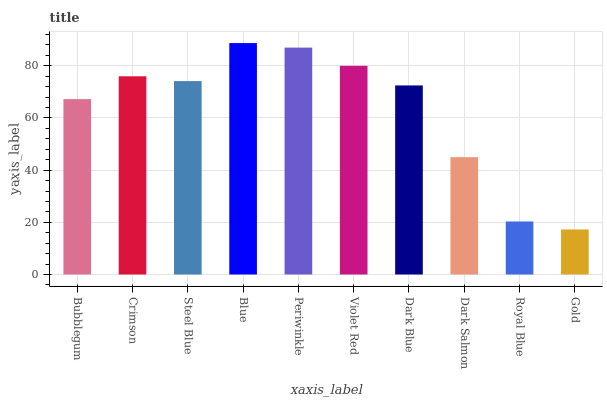Is Gold the minimum?
Answer yes or no. Yes. Is Blue the maximum?
Answer yes or no. Yes. Is Crimson the minimum?
Answer yes or no. No. Is Crimson the maximum?
Answer yes or no. No. Is Crimson greater than Bubblegum?
Answer yes or no. Yes. Is Bubblegum less than Crimson?
Answer yes or no. Yes. Is Bubblegum greater than Crimson?
Answer yes or no. No. Is Crimson less than Bubblegum?
Answer yes or no. No. Is Steel Blue the high median?
Answer yes or no. Yes. Is Dark Blue the low median?
Answer yes or no. Yes. Is Royal Blue the high median?
Answer yes or no. No. Is Periwinkle the low median?
Answer yes or no. No. 